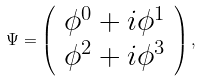Convert formula to latex. <formula><loc_0><loc_0><loc_500><loc_500>\Psi = \left ( \begin{array} { l } \phi ^ { 0 } + i \phi ^ { 1 } \\ \phi ^ { 2 } + i \phi ^ { 3 } \end{array} \right ) , \,</formula> 